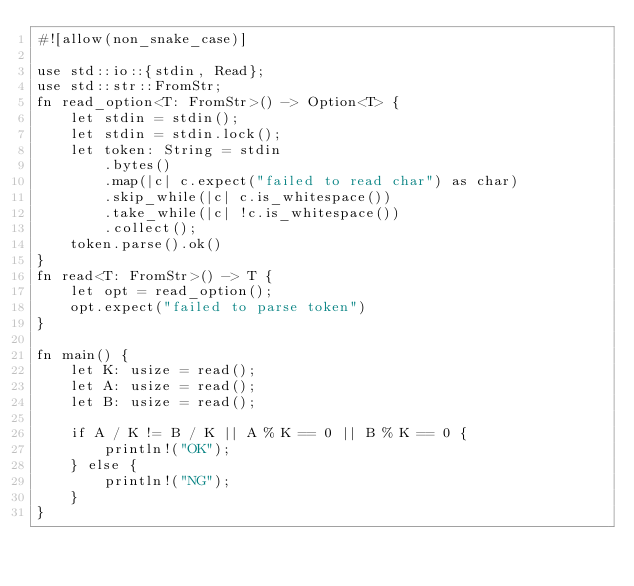<code> <loc_0><loc_0><loc_500><loc_500><_Rust_>#![allow(non_snake_case)]

use std::io::{stdin, Read};
use std::str::FromStr;
fn read_option<T: FromStr>() -> Option<T> {
    let stdin = stdin();
    let stdin = stdin.lock();
    let token: String = stdin
        .bytes()
        .map(|c| c.expect("failed to read char") as char)
        .skip_while(|c| c.is_whitespace())
        .take_while(|c| !c.is_whitespace())
        .collect();
    token.parse().ok()
}
fn read<T: FromStr>() -> T {
    let opt = read_option();
    opt.expect("failed to parse token")
}

fn main() {
    let K: usize = read();
    let A: usize = read();
    let B: usize = read();

    if A / K != B / K || A % K == 0 || B % K == 0 {
        println!("OK");
    } else {
        println!("NG");
    }
}
</code> 